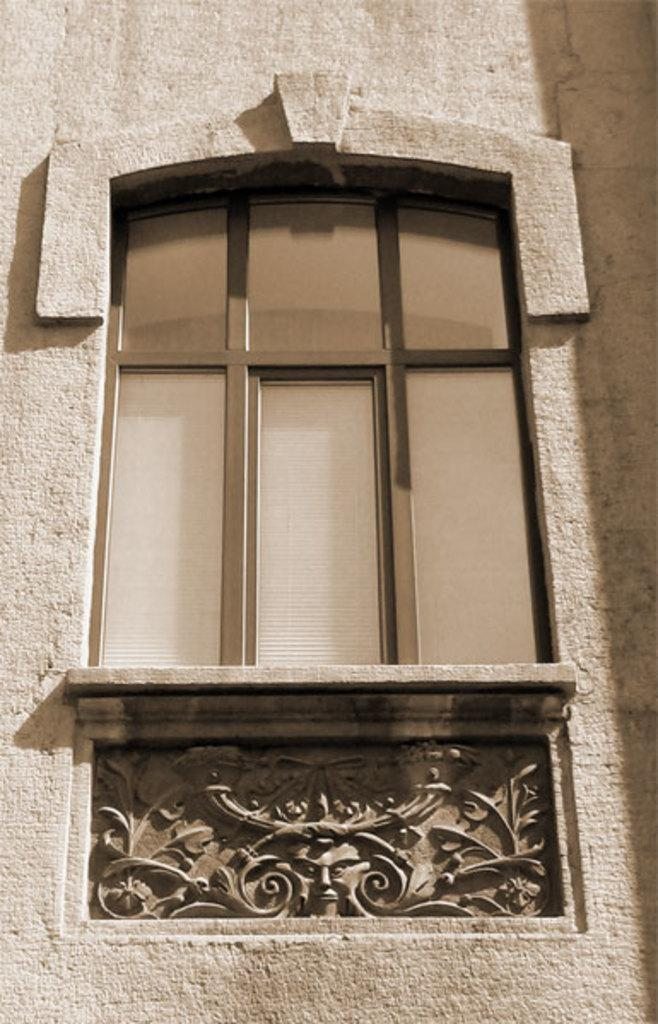What is the main subject of the image? The main subject of the image is a window. What type of structure is the window a part of? The window belongs to a building. What type of knowledge is displayed in the locket hanging from the window in the image? There is no locket or any form of knowledge displayed in the image; it is a zoomed-in picture of a window. 